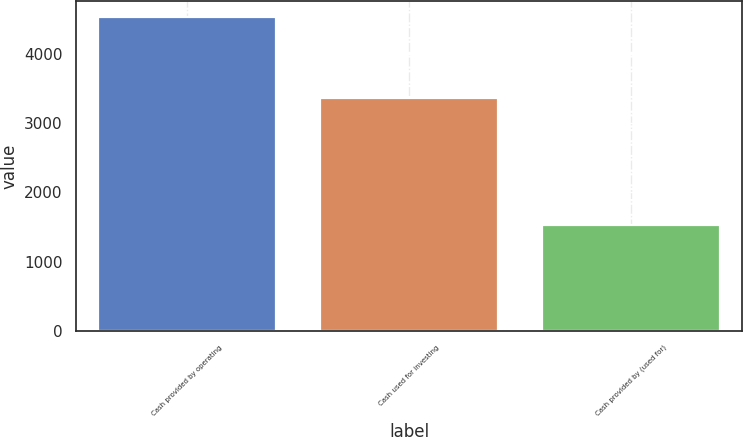Convert chart to OTSL. <chart><loc_0><loc_0><loc_500><loc_500><bar_chart><fcel>Cash provided by operating<fcel>Cash used for investing<fcel>Cash provided by (used for)<nl><fcel>4541<fcel>3359<fcel>1527<nl></chart> 